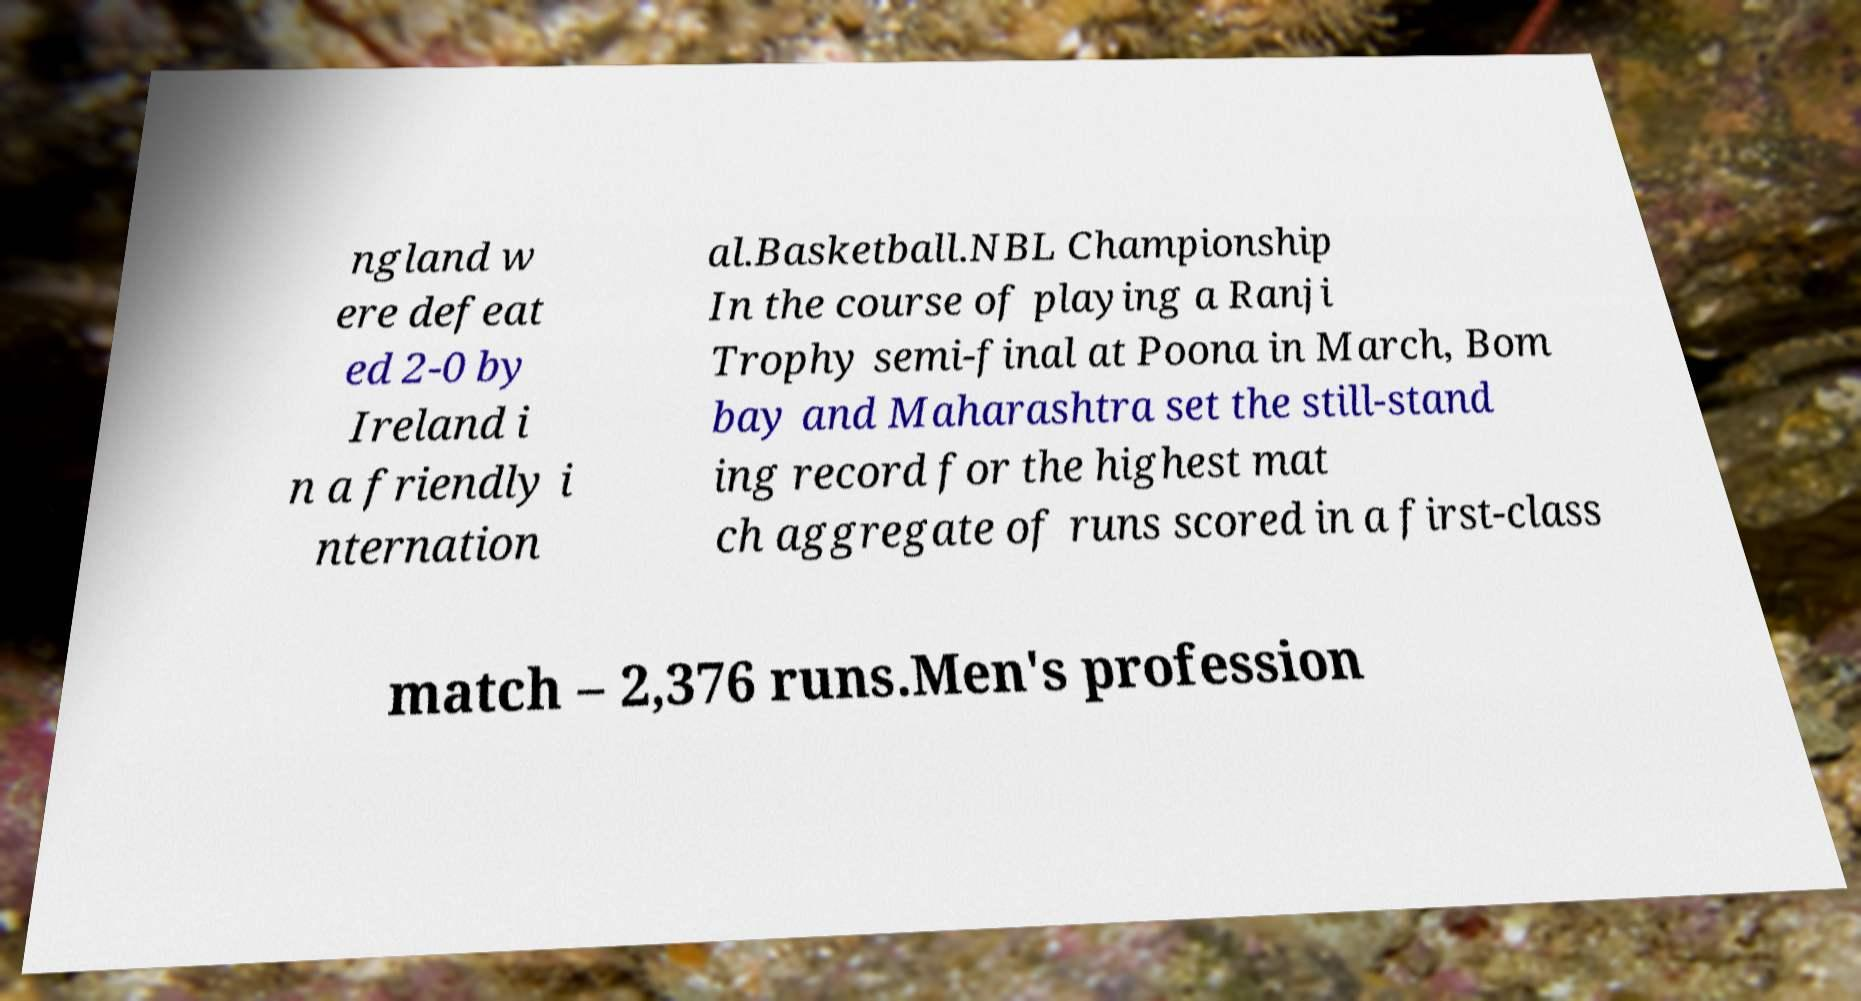There's text embedded in this image that I need extracted. Can you transcribe it verbatim? ngland w ere defeat ed 2-0 by Ireland i n a friendly i nternation al.Basketball.NBL Championship In the course of playing a Ranji Trophy semi-final at Poona in March, Bom bay and Maharashtra set the still-stand ing record for the highest mat ch aggregate of runs scored in a first-class match – 2,376 runs.Men's profession 